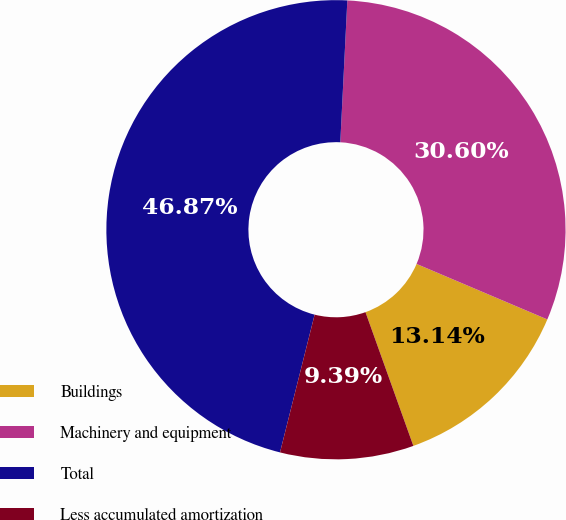Convert chart. <chart><loc_0><loc_0><loc_500><loc_500><pie_chart><fcel>Buildings<fcel>Machinery and equipment<fcel>Total<fcel>Less accumulated amortization<nl><fcel>13.14%<fcel>30.6%<fcel>46.87%<fcel>9.39%<nl></chart> 